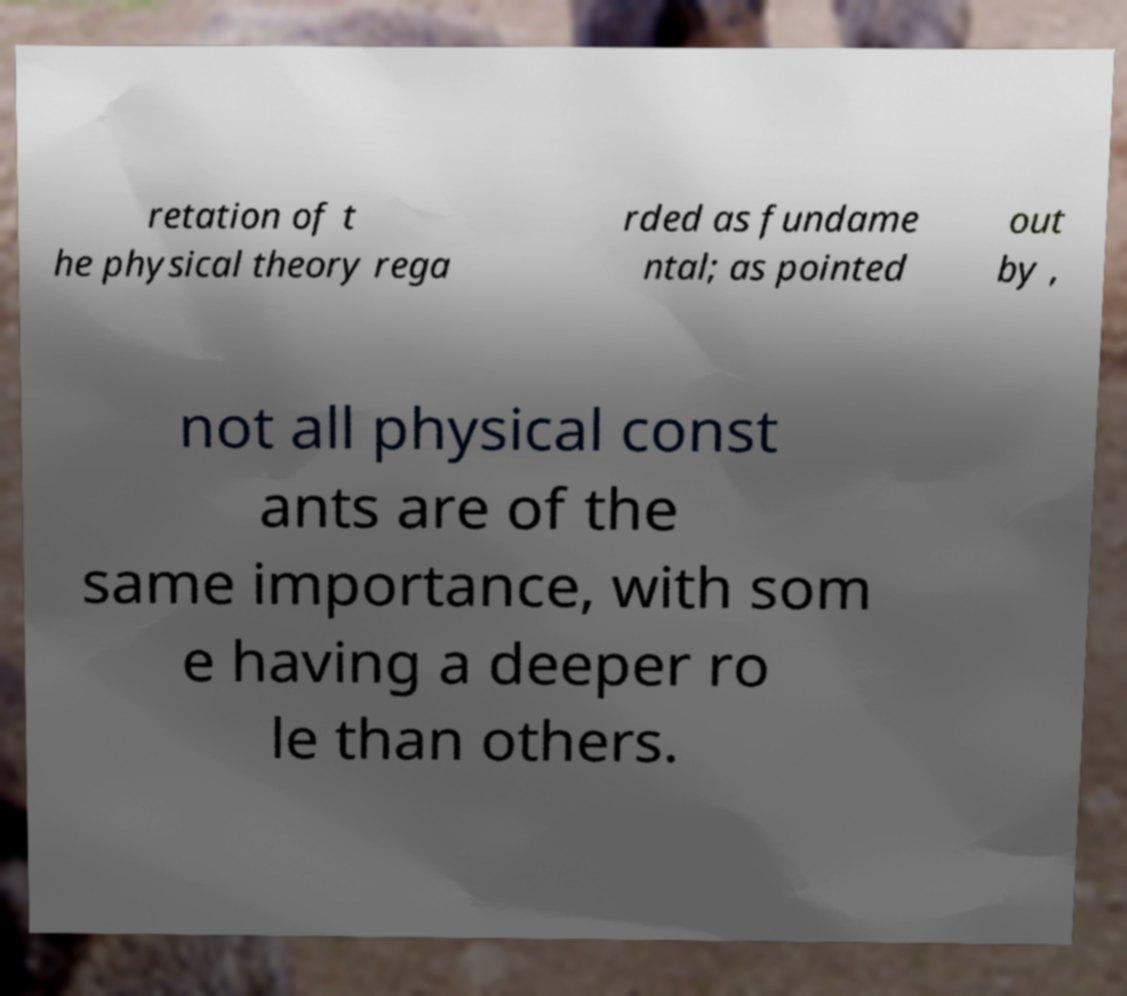Please read and relay the text visible in this image. What does it say? retation of t he physical theory rega rded as fundame ntal; as pointed out by , not all physical const ants are of the same importance, with som e having a deeper ro le than others. 